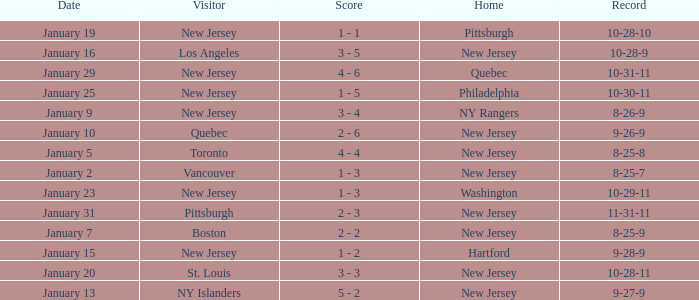What was the date that ended in a record of 8-25-7? January 2. 